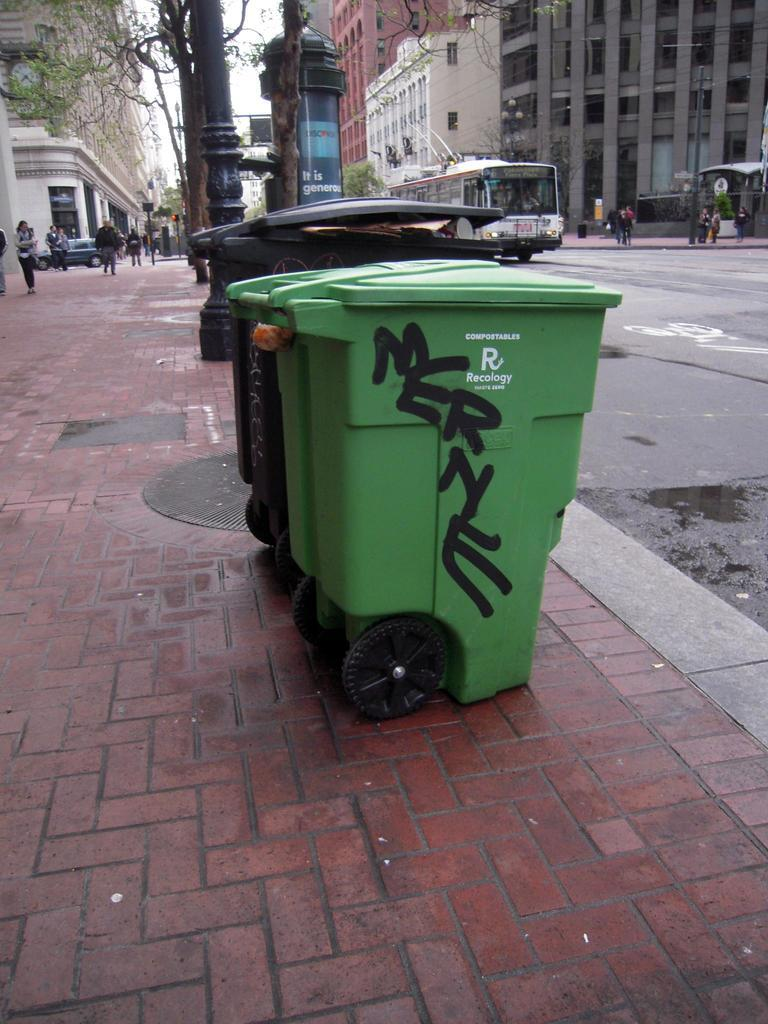<image>
Create a compact narrative representing the image presented. A green Recology compostables bin with graffiti on it. 